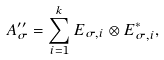Convert formula to latex. <formula><loc_0><loc_0><loc_500><loc_500>A _ { \sigma } ^ { \prime \prime } = \sum _ { i = 1 } ^ { k } E _ { \sigma , i } \otimes E _ { \sigma , i } ^ { * } ,</formula> 